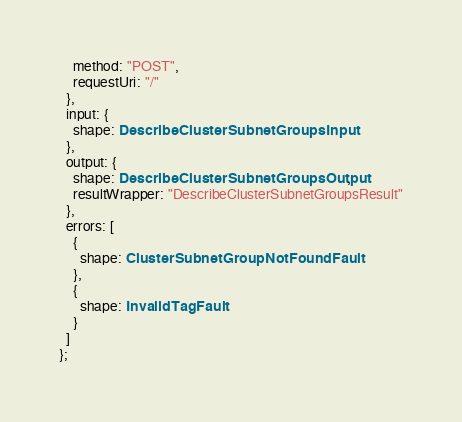Convert code to text. <code><loc_0><loc_0><loc_500><loc_500><_TypeScript_>    method: "POST",
    requestUri: "/"
  },
  input: {
    shape: DescribeClusterSubnetGroupsInput
  },
  output: {
    shape: DescribeClusterSubnetGroupsOutput,
    resultWrapper: "DescribeClusterSubnetGroupsResult"
  },
  errors: [
    {
      shape: ClusterSubnetGroupNotFoundFault
    },
    {
      shape: InvalidTagFault
    }
  ]
};
</code> 